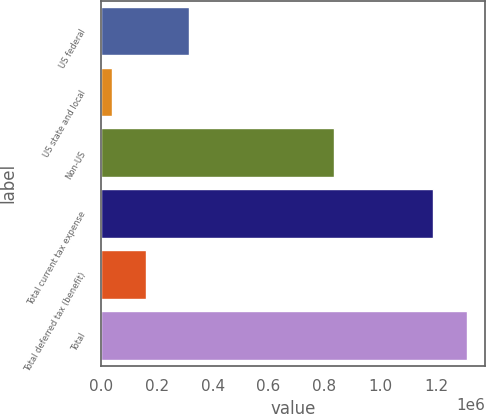Convert chart. <chart><loc_0><loc_0><loc_500><loc_500><bar_chart><fcel>US federal<fcel>US state and local<fcel>Non-US<fcel>Total current tax expense<fcel>Total deferred tax (benefit)<fcel>Total<nl><fcel>314121<fcel>38255<fcel>835653<fcel>1.18803e+06<fcel>159826<fcel>1.3096e+06<nl></chart> 